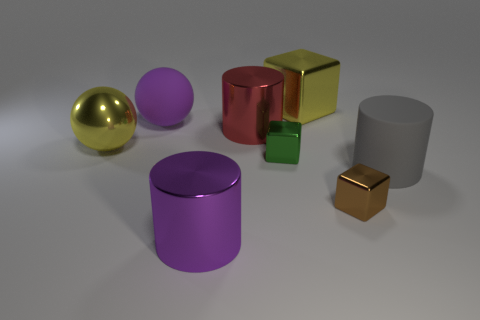Subtract all purple balls. Subtract all blue blocks. How many balls are left? 1 Add 1 large cylinders. How many objects exist? 9 Subtract all cylinders. How many objects are left? 5 Subtract all yellow blocks. Subtract all large yellow spheres. How many objects are left? 6 Add 8 spheres. How many spheres are left? 10 Add 1 big green spheres. How many big green spheres exist? 1 Subtract 0 cyan spheres. How many objects are left? 8 